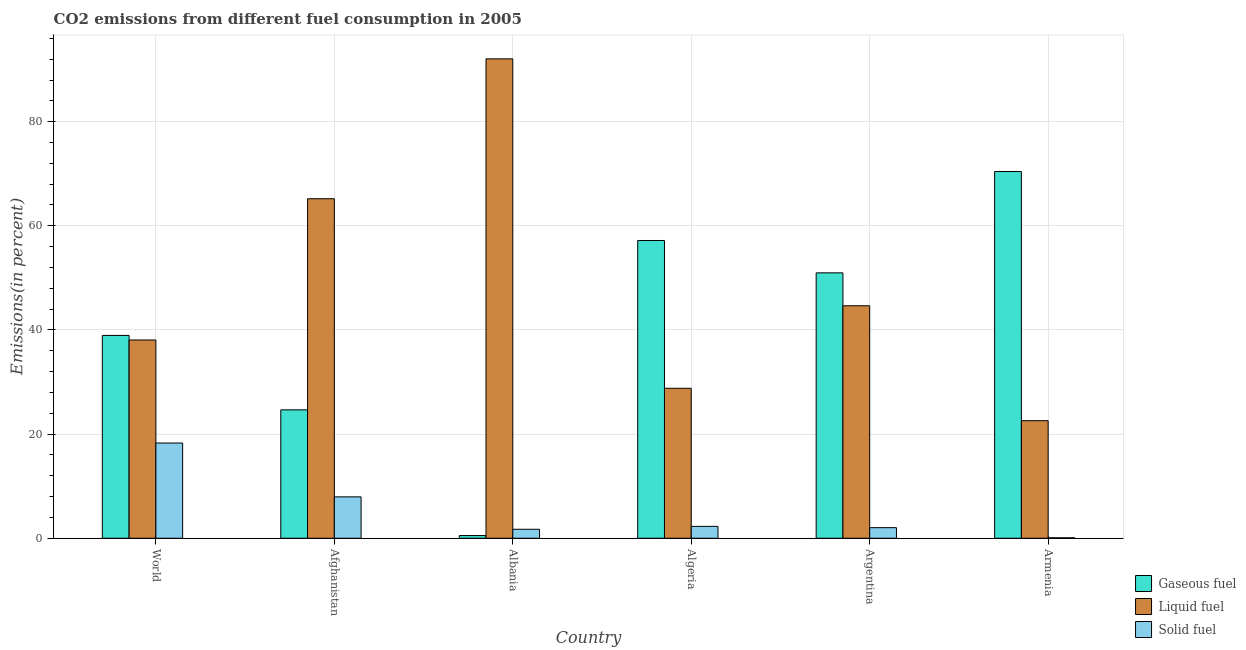How many groups of bars are there?
Offer a very short reply. 6. Are the number of bars per tick equal to the number of legend labels?
Offer a terse response. Yes. What is the label of the 3rd group of bars from the left?
Give a very brief answer. Albania. What is the percentage of liquid fuel emission in World?
Keep it short and to the point. 38.08. Across all countries, what is the maximum percentage of gaseous fuel emission?
Your response must be concise. 70.43. Across all countries, what is the minimum percentage of liquid fuel emission?
Your answer should be very brief. 22.58. In which country was the percentage of gaseous fuel emission maximum?
Provide a short and direct response. Armenia. In which country was the percentage of solid fuel emission minimum?
Your answer should be compact. Armenia. What is the total percentage of liquid fuel emission in the graph?
Your response must be concise. 291.37. What is the difference between the percentage of solid fuel emission in Algeria and that in Armenia?
Offer a very short reply. 2.2. What is the difference between the percentage of liquid fuel emission in Argentina and the percentage of gaseous fuel emission in World?
Your answer should be very brief. 5.69. What is the average percentage of liquid fuel emission per country?
Ensure brevity in your answer.  48.56. What is the difference between the percentage of liquid fuel emission and percentage of solid fuel emission in World?
Provide a short and direct response. 19.79. What is the ratio of the percentage of liquid fuel emission in Albania to that in Armenia?
Offer a very short reply. 4.08. What is the difference between the highest and the second highest percentage of liquid fuel emission?
Your response must be concise. 26.86. What is the difference between the highest and the lowest percentage of solid fuel emission?
Your answer should be compact. 18.2. What does the 1st bar from the left in Argentina represents?
Your answer should be very brief. Gaseous fuel. What does the 1st bar from the right in World represents?
Your answer should be very brief. Solid fuel. Is it the case that in every country, the sum of the percentage of gaseous fuel emission and percentage of liquid fuel emission is greater than the percentage of solid fuel emission?
Provide a short and direct response. Yes. Are the values on the major ticks of Y-axis written in scientific E-notation?
Offer a terse response. No. How many legend labels are there?
Offer a very short reply. 3. How are the legend labels stacked?
Your answer should be compact. Vertical. What is the title of the graph?
Make the answer very short. CO2 emissions from different fuel consumption in 2005. What is the label or title of the X-axis?
Provide a succinct answer. Country. What is the label or title of the Y-axis?
Provide a succinct answer. Emissions(in percent). What is the Emissions(in percent) of Gaseous fuel in World?
Make the answer very short. 38.95. What is the Emissions(in percent) of Liquid fuel in World?
Provide a succinct answer. 38.08. What is the Emissions(in percent) of Solid fuel in World?
Your answer should be compact. 18.29. What is the Emissions(in percent) in Gaseous fuel in Afghanistan?
Offer a very short reply. 24.66. What is the Emissions(in percent) in Liquid fuel in Afghanistan?
Provide a short and direct response. 65.21. What is the Emissions(in percent) in Solid fuel in Afghanistan?
Ensure brevity in your answer.  7.95. What is the Emissions(in percent) of Gaseous fuel in Albania?
Make the answer very short. 0.52. What is the Emissions(in percent) of Liquid fuel in Albania?
Your answer should be compact. 92.07. What is the Emissions(in percent) of Solid fuel in Albania?
Give a very brief answer. 1.72. What is the Emissions(in percent) of Gaseous fuel in Algeria?
Make the answer very short. 57.18. What is the Emissions(in percent) of Liquid fuel in Algeria?
Ensure brevity in your answer.  28.8. What is the Emissions(in percent) in Solid fuel in Algeria?
Your answer should be very brief. 2.28. What is the Emissions(in percent) in Gaseous fuel in Argentina?
Offer a very short reply. 50.97. What is the Emissions(in percent) of Liquid fuel in Argentina?
Provide a short and direct response. 44.65. What is the Emissions(in percent) in Solid fuel in Argentina?
Offer a very short reply. 2.03. What is the Emissions(in percent) of Gaseous fuel in Armenia?
Your response must be concise. 70.43. What is the Emissions(in percent) of Liquid fuel in Armenia?
Offer a terse response. 22.58. What is the Emissions(in percent) of Solid fuel in Armenia?
Keep it short and to the point. 0.08. Across all countries, what is the maximum Emissions(in percent) of Gaseous fuel?
Ensure brevity in your answer.  70.43. Across all countries, what is the maximum Emissions(in percent) of Liquid fuel?
Make the answer very short. 92.07. Across all countries, what is the maximum Emissions(in percent) of Solid fuel?
Make the answer very short. 18.29. Across all countries, what is the minimum Emissions(in percent) in Gaseous fuel?
Ensure brevity in your answer.  0.52. Across all countries, what is the minimum Emissions(in percent) of Liquid fuel?
Provide a succinct answer. 22.58. Across all countries, what is the minimum Emissions(in percent) in Solid fuel?
Make the answer very short. 0.08. What is the total Emissions(in percent) of Gaseous fuel in the graph?
Give a very brief answer. 242.71. What is the total Emissions(in percent) of Liquid fuel in the graph?
Provide a short and direct response. 291.37. What is the total Emissions(in percent) of Solid fuel in the graph?
Your response must be concise. 32.35. What is the difference between the Emissions(in percent) in Gaseous fuel in World and that in Afghanistan?
Your answer should be very brief. 14.3. What is the difference between the Emissions(in percent) of Liquid fuel in World and that in Afghanistan?
Make the answer very short. -27.13. What is the difference between the Emissions(in percent) in Solid fuel in World and that in Afghanistan?
Ensure brevity in your answer.  10.34. What is the difference between the Emissions(in percent) of Gaseous fuel in World and that in Albania?
Your answer should be very brief. 38.44. What is the difference between the Emissions(in percent) of Liquid fuel in World and that in Albania?
Keep it short and to the point. -53.99. What is the difference between the Emissions(in percent) of Solid fuel in World and that in Albania?
Make the answer very short. 16.56. What is the difference between the Emissions(in percent) in Gaseous fuel in World and that in Algeria?
Provide a short and direct response. -18.23. What is the difference between the Emissions(in percent) of Liquid fuel in World and that in Algeria?
Provide a succinct answer. 9.28. What is the difference between the Emissions(in percent) of Solid fuel in World and that in Algeria?
Give a very brief answer. 16.01. What is the difference between the Emissions(in percent) of Gaseous fuel in World and that in Argentina?
Your response must be concise. -12.01. What is the difference between the Emissions(in percent) in Liquid fuel in World and that in Argentina?
Make the answer very short. -6.57. What is the difference between the Emissions(in percent) of Solid fuel in World and that in Argentina?
Your response must be concise. 16.26. What is the difference between the Emissions(in percent) in Gaseous fuel in World and that in Armenia?
Your answer should be compact. -31.47. What is the difference between the Emissions(in percent) in Liquid fuel in World and that in Armenia?
Your answer should be compact. 15.5. What is the difference between the Emissions(in percent) in Solid fuel in World and that in Armenia?
Provide a succinct answer. 18.2. What is the difference between the Emissions(in percent) of Gaseous fuel in Afghanistan and that in Albania?
Ensure brevity in your answer.  24.14. What is the difference between the Emissions(in percent) in Liquid fuel in Afghanistan and that in Albania?
Your answer should be very brief. -26.86. What is the difference between the Emissions(in percent) in Solid fuel in Afghanistan and that in Albania?
Offer a terse response. 6.22. What is the difference between the Emissions(in percent) in Gaseous fuel in Afghanistan and that in Algeria?
Your answer should be compact. -32.53. What is the difference between the Emissions(in percent) of Liquid fuel in Afghanistan and that in Algeria?
Provide a succinct answer. 36.41. What is the difference between the Emissions(in percent) in Solid fuel in Afghanistan and that in Algeria?
Make the answer very short. 5.67. What is the difference between the Emissions(in percent) in Gaseous fuel in Afghanistan and that in Argentina?
Give a very brief answer. -26.31. What is the difference between the Emissions(in percent) of Liquid fuel in Afghanistan and that in Argentina?
Your answer should be very brief. 20.56. What is the difference between the Emissions(in percent) in Solid fuel in Afghanistan and that in Argentina?
Offer a terse response. 5.91. What is the difference between the Emissions(in percent) in Gaseous fuel in Afghanistan and that in Armenia?
Give a very brief answer. -45.77. What is the difference between the Emissions(in percent) in Liquid fuel in Afghanistan and that in Armenia?
Your response must be concise. 42.63. What is the difference between the Emissions(in percent) in Solid fuel in Afghanistan and that in Armenia?
Your response must be concise. 7.86. What is the difference between the Emissions(in percent) of Gaseous fuel in Albania and that in Algeria?
Provide a succinct answer. -56.67. What is the difference between the Emissions(in percent) in Liquid fuel in Albania and that in Algeria?
Your answer should be very brief. 63.27. What is the difference between the Emissions(in percent) in Solid fuel in Albania and that in Algeria?
Offer a very short reply. -0.56. What is the difference between the Emissions(in percent) of Gaseous fuel in Albania and that in Argentina?
Offer a very short reply. -50.45. What is the difference between the Emissions(in percent) in Liquid fuel in Albania and that in Argentina?
Offer a very short reply. 47.42. What is the difference between the Emissions(in percent) of Solid fuel in Albania and that in Argentina?
Make the answer very short. -0.31. What is the difference between the Emissions(in percent) of Gaseous fuel in Albania and that in Armenia?
Your answer should be compact. -69.91. What is the difference between the Emissions(in percent) of Liquid fuel in Albania and that in Armenia?
Offer a terse response. 69.49. What is the difference between the Emissions(in percent) in Solid fuel in Albania and that in Armenia?
Provide a short and direct response. 1.64. What is the difference between the Emissions(in percent) in Gaseous fuel in Algeria and that in Argentina?
Keep it short and to the point. 6.22. What is the difference between the Emissions(in percent) in Liquid fuel in Algeria and that in Argentina?
Keep it short and to the point. -15.85. What is the difference between the Emissions(in percent) in Solid fuel in Algeria and that in Argentina?
Provide a short and direct response. 0.25. What is the difference between the Emissions(in percent) in Gaseous fuel in Algeria and that in Armenia?
Provide a short and direct response. -13.24. What is the difference between the Emissions(in percent) of Liquid fuel in Algeria and that in Armenia?
Offer a terse response. 6.22. What is the difference between the Emissions(in percent) of Solid fuel in Algeria and that in Armenia?
Ensure brevity in your answer.  2.2. What is the difference between the Emissions(in percent) in Gaseous fuel in Argentina and that in Armenia?
Give a very brief answer. -19.46. What is the difference between the Emissions(in percent) of Liquid fuel in Argentina and that in Armenia?
Give a very brief answer. 22.07. What is the difference between the Emissions(in percent) of Solid fuel in Argentina and that in Armenia?
Ensure brevity in your answer.  1.95. What is the difference between the Emissions(in percent) in Gaseous fuel in World and the Emissions(in percent) in Liquid fuel in Afghanistan?
Give a very brief answer. -26.25. What is the difference between the Emissions(in percent) in Gaseous fuel in World and the Emissions(in percent) in Solid fuel in Afghanistan?
Provide a succinct answer. 31.01. What is the difference between the Emissions(in percent) in Liquid fuel in World and the Emissions(in percent) in Solid fuel in Afghanistan?
Offer a very short reply. 30.13. What is the difference between the Emissions(in percent) in Gaseous fuel in World and the Emissions(in percent) in Liquid fuel in Albania?
Offer a very short reply. -53.11. What is the difference between the Emissions(in percent) in Gaseous fuel in World and the Emissions(in percent) in Solid fuel in Albania?
Make the answer very short. 37.23. What is the difference between the Emissions(in percent) in Liquid fuel in World and the Emissions(in percent) in Solid fuel in Albania?
Your response must be concise. 36.35. What is the difference between the Emissions(in percent) in Gaseous fuel in World and the Emissions(in percent) in Liquid fuel in Algeria?
Make the answer very short. 10.16. What is the difference between the Emissions(in percent) in Gaseous fuel in World and the Emissions(in percent) in Solid fuel in Algeria?
Make the answer very short. 36.68. What is the difference between the Emissions(in percent) in Liquid fuel in World and the Emissions(in percent) in Solid fuel in Algeria?
Make the answer very short. 35.8. What is the difference between the Emissions(in percent) in Gaseous fuel in World and the Emissions(in percent) in Liquid fuel in Argentina?
Provide a succinct answer. -5.69. What is the difference between the Emissions(in percent) in Gaseous fuel in World and the Emissions(in percent) in Solid fuel in Argentina?
Your answer should be compact. 36.92. What is the difference between the Emissions(in percent) in Liquid fuel in World and the Emissions(in percent) in Solid fuel in Argentina?
Keep it short and to the point. 36.04. What is the difference between the Emissions(in percent) in Gaseous fuel in World and the Emissions(in percent) in Liquid fuel in Armenia?
Provide a succinct answer. 16.38. What is the difference between the Emissions(in percent) of Gaseous fuel in World and the Emissions(in percent) of Solid fuel in Armenia?
Make the answer very short. 38.87. What is the difference between the Emissions(in percent) in Liquid fuel in World and the Emissions(in percent) in Solid fuel in Armenia?
Your answer should be very brief. 37.99. What is the difference between the Emissions(in percent) of Gaseous fuel in Afghanistan and the Emissions(in percent) of Liquid fuel in Albania?
Your answer should be very brief. -67.41. What is the difference between the Emissions(in percent) of Gaseous fuel in Afghanistan and the Emissions(in percent) of Solid fuel in Albania?
Your answer should be very brief. 22.93. What is the difference between the Emissions(in percent) of Liquid fuel in Afghanistan and the Emissions(in percent) of Solid fuel in Albania?
Keep it short and to the point. 63.48. What is the difference between the Emissions(in percent) in Gaseous fuel in Afghanistan and the Emissions(in percent) in Liquid fuel in Algeria?
Provide a succinct answer. -4.14. What is the difference between the Emissions(in percent) of Gaseous fuel in Afghanistan and the Emissions(in percent) of Solid fuel in Algeria?
Offer a very short reply. 22.38. What is the difference between the Emissions(in percent) in Liquid fuel in Afghanistan and the Emissions(in percent) in Solid fuel in Algeria?
Your answer should be very brief. 62.93. What is the difference between the Emissions(in percent) of Gaseous fuel in Afghanistan and the Emissions(in percent) of Liquid fuel in Argentina?
Ensure brevity in your answer.  -19.99. What is the difference between the Emissions(in percent) in Gaseous fuel in Afghanistan and the Emissions(in percent) in Solid fuel in Argentina?
Provide a succinct answer. 22.63. What is the difference between the Emissions(in percent) of Liquid fuel in Afghanistan and the Emissions(in percent) of Solid fuel in Argentina?
Provide a succinct answer. 63.17. What is the difference between the Emissions(in percent) of Gaseous fuel in Afghanistan and the Emissions(in percent) of Liquid fuel in Armenia?
Give a very brief answer. 2.08. What is the difference between the Emissions(in percent) of Gaseous fuel in Afghanistan and the Emissions(in percent) of Solid fuel in Armenia?
Offer a very short reply. 24.57. What is the difference between the Emissions(in percent) of Liquid fuel in Afghanistan and the Emissions(in percent) of Solid fuel in Armenia?
Your answer should be very brief. 65.12. What is the difference between the Emissions(in percent) of Gaseous fuel in Albania and the Emissions(in percent) of Liquid fuel in Algeria?
Give a very brief answer. -28.28. What is the difference between the Emissions(in percent) of Gaseous fuel in Albania and the Emissions(in percent) of Solid fuel in Algeria?
Your answer should be compact. -1.76. What is the difference between the Emissions(in percent) in Liquid fuel in Albania and the Emissions(in percent) in Solid fuel in Algeria?
Your response must be concise. 89.79. What is the difference between the Emissions(in percent) in Gaseous fuel in Albania and the Emissions(in percent) in Liquid fuel in Argentina?
Your response must be concise. -44.13. What is the difference between the Emissions(in percent) in Gaseous fuel in Albania and the Emissions(in percent) in Solid fuel in Argentina?
Keep it short and to the point. -1.51. What is the difference between the Emissions(in percent) of Liquid fuel in Albania and the Emissions(in percent) of Solid fuel in Argentina?
Your answer should be very brief. 90.04. What is the difference between the Emissions(in percent) in Gaseous fuel in Albania and the Emissions(in percent) in Liquid fuel in Armenia?
Your response must be concise. -22.06. What is the difference between the Emissions(in percent) in Gaseous fuel in Albania and the Emissions(in percent) in Solid fuel in Armenia?
Provide a short and direct response. 0.43. What is the difference between the Emissions(in percent) in Liquid fuel in Albania and the Emissions(in percent) in Solid fuel in Armenia?
Your answer should be compact. 91.98. What is the difference between the Emissions(in percent) in Gaseous fuel in Algeria and the Emissions(in percent) in Liquid fuel in Argentina?
Ensure brevity in your answer.  12.54. What is the difference between the Emissions(in percent) in Gaseous fuel in Algeria and the Emissions(in percent) in Solid fuel in Argentina?
Your answer should be very brief. 55.15. What is the difference between the Emissions(in percent) in Liquid fuel in Algeria and the Emissions(in percent) in Solid fuel in Argentina?
Ensure brevity in your answer.  26.77. What is the difference between the Emissions(in percent) in Gaseous fuel in Algeria and the Emissions(in percent) in Liquid fuel in Armenia?
Your response must be concise. 34.61. What is the difference between the Emissions(in percent) in Gaseous fuel in Algeria and the Emissions(in percent) in Solid fuel in Armenia?
Your response must be concise. 57.1. What is the difference between the Emissions(in percent) in Liquid fuel in Algeria and the Emissions(in percent) in Solid fuel in Armenia?
Your answer should be compact. 28.71. What is the difference between the Emissions(in percent) of Gaseous fuel in Argentina and the Emissions(in percent) of Liquid fuel in Armenia?
Your response must be concise. 28.39. What is the difference between the Emissions(in percent) of Gaseous fuel in Argentina and the Emissions(in percent) of Solid fuel in Armenia?
Provide a short and direct response. 50.88. What is the difference between the Emissions(in percent) of Liquid fuel in Argentina and the Emissions(in percent) of Solid fuel in Armenia?
Offer a terse response. 44.56. What is the average Emissions(in percent) in Gaseous fuel per country?
Provide a short and direct response. 40.45. What is the average Emissions(in percent) in Liquid fuel per country?
Provide a succinct answer. 48.56. What is the average Emissions(in percent) in Solid fuel per country?
Your answer should be very brief. 5.39. What is the difference between the Emissions(in percent) of Gaseous fuel and Emissions(in percent) of Liquid fuel in World?
Offer a very short reply. 0.88. What is the difference between the Emissions(in percent) in Gaseous fuel and Emissions(in percent) in Solid fuel in World?
Your response must be concise. 20.67. What is the difference between the Emissions(in percent) in Liquid fuel and Emissions(in percent) in Solid fuel in World?
Offer a very short reply. 19.79. What is the difference between the Emissions(in percent) of Gaseous fuel and Emissions(in percent) of Liquid fuel in Afghanistan?
Offer a terse response. -40.55. What is the difference between the Emissions(in percent) in Gaseous fuel and Emissions(in percent) in Solid fuel in Afghanistan?
Offer a very short reply. 16.71. What is the difference between the Emissions(in percent) of Liquid fuel and Emissions(in percent) of Solid fuel in Afghanistan?
Your answer should be very brief. 57.26. What is the difference between the Emissions(in percent) of Gaseous fuel and Emissions(in percent) of Liquid fuel in Albania?
Provide a succinct answer. -91.55. What is the difference between the Emissions(in percent) of Gaseous fuel and Emissions(in percent) of Solid fuel in Albania?
Provide a succinct answer. -1.21. What is the difference between the Emissions(in percent) in Liquid fuel and Emissions(in percent) in Solid fuel in Albania?
Your response must be concise. 90.34. What is the difference between the Emissions(in percent) in Gaseous fuel and Emissions(in percent) in Liquid fuel in Algeria?
Offer a terse response. 28.39. What is the difference between the Emissions(in percent) in Gaseous fuel and Emissions(in percent) in Solid fuel in Algeria?
Ensure brevity in your answer.  54.91. What is the difference between the Emissions(in percent) of Liquid fuel and Emissions(in percent) of Solid fuel in Algeria?
Provide a short and direct response. 26.52. What is the difference between the Emissions(in percent) of Gaseous fuel and Emissions(in percent) of Liquid fuel in Argentina?
Offer a terse response. 6.32. What is the difference between the Emissions(in percent) of Gaseous fuel and Emissions(in percent) of Solid fuel in Argentina?
Make the answer very short. 48.94. What is the difference between the Emissions(in percent) in Liquid fuel and Emissions(in percent) in Solid fuel in Argentina?
Provide a short and direct response. 42.61. What is the difference between the Emissions(in percent) of Gaseous fuel and Emissions(in percent) of Liquid fuel in Armenia?
Make the answer very short. 47.85. What is the difference between the Emissions(in percent) of Gaseous fuel and Emissions(in percent) of Solid fuel in Armenia?
Keep it short and to the point. 70.35. What is the difference between the Emissions(in percent) in Liquid fuel and Emissions(in percent) in Solid fuel in Armenia?
Your answer should be compact. 22.49. What is the ratio of the Emissions(in percent) of Gaseous fuel in World to that in Afghanistan?
Your answer should be compact. 1.58. What is the ratio of the Emissions(in percent) of Liquid fuel in World to that in Afghanistan?
Make the answer very short. 0.58. What is the ratio of the Emissions(in percent) of Solid fuel in World to that in Afghanistan?
Your answer should be very brief. 2.3. What is the ratio of the Emissions(in percent) of Gaseous fuel in World to that in Albania?
Ensure brevity in your answer.  75.31. What is the ratio of the Emissions(in percent) in Liquid fuel in World to that in Albania?
Keep it short and to the point. 0.41. What is the ratio of the Emissions(in percent) of Solid fuel in World to that in Albania?
Give a very brief answer. 10.61. What is the ratio of the Emissions(in percent) in Gaseous fuel in World to that in Algeria?
Your answer should be very brief. 0.68. What is the ratio of the Emissions(in percent) of Liquid fuel in World to that in Algeria?
Give a very brief answer. 1.32. What is the ratio of the Emissions(in percent) in Solid fuel in World to that in Algeria?
Your answer should be compact. 8.02. What is the ratio of the Emissions(in percent) in Gaseous fuel in World to that in Argentina?
Give a very brief answer. 0.76. What is the ratio of the Emissions(in percent) in Liquid fuel in World to that in Argentina?
Your response must be concise. 0.85. What is the ratio of the Emissions(in percent) of Solid fuel in World to that in Argentina?
Keep it short and to the point. 9. What is the ratio of the Emissions(in percent) of Gaseous fuel in World to that in Armenia?
Give a very brief answer. 0.55. What is the ratio of the Emissions(in percent) of Liquid fuel in World to that in Armenia?
Your answer should be very brief. 1.69. What is the ratio of the Emissions(in percent) in Solid fuel in World to that in Armenia?
Your answer should be compact. 217.09. What is the ratio of the Emissions(in percent) of Gaseous fuel in Afghanistan to that in Albania?
Provide a succinct answer. 47.67. What is the ratio of the Emissions(in percent) in Liquid fuel in Afghanistan to that in Albania?
Keep it short and to the point. 0.71. What is the ratio of the Emissions(in percent) of Solid fuel in Afghanistan to that in Albania?
Provide a short and direct response. 4.61. What is the ratio of the Emissions(in percent) of Gaseous fuel in Afghanistan to that in Algeria?
Provide a succinct answer. 0.43. What is the ratio of the Emissions(in percent) of Liquid fuel in Afghanistan to that in Algeria?
Ensure brevity in your answer.  2.26. What is the ratio of the Emissions(in percent) of Solid fuel in Afghanistan to that in Algeria?
Offer a terse response. 3.49. What is the ratio of the Emissions(in percent) of Gaseous fuel in Afghanistan to that in Argentina?
Offer a very short reply. 0.48. What is the ratio of the Emissions(in percent) of Liquid fuel in Afghanistan to that in Argentina?
Keep it short and to the point. 1.46. What is the ratio of the Emissions(in percent) of Solid fuel in Afghanistan to that in Argentina?
Give a very brief answer. 3.91. What is the ratio of the Emissions(in percent) of Gaseous fuel in Afghanistan to that in Armenia?
Provide a succinct answer. 0.35. What is the ratio of the Emissions(in percent) of Liquid fuel in Afghanistan to that in Armenia?
Offer a very short reply. 2.89. What is the ratio of the Emissions(in percent) of Solid fuel in Afghanistan to that in Armenia?
Your answer should be very brief. 94.31. What is the ratio of the Emissions(in percent) in Gaseous fuel in Albania to that in Algeria?
Ensure brevity in your answer.  0.01. What is the ratio of the Emissions(in percent) in Liquid fuel in Albania to that in Algeria?
Your answer should be compact. 3.2. What is the ratio of the Emissions(in percent) in Solid fuel in Albania to that in Algeria?
Ensure brevity in your answer.  0.76. What is the ratio of the Emissions(in percent) of Gaseous fuel in Albania to that in Argentina?
Provide a short and direct response. 0.01. What is the ratio of the Emissions(in percent) of Liquid fuel in Albania to that in Argentina?
Provide a short and direct response. 2.06. What is the ratio of the Emissions(in percent) in Solid fuel in Albania to that in Argentina?
Offer a very short reply. 0.85. What is the ratio of the Emissions(in percent) of Gaseous fuel in Albania to that in Armenia?
Provide a succinct answer. 0.01. What is the ratio of the Emissions(in percent) in Liquid fuel in Albania to that in Armenia?
Offer a terse response. 4.08. What is the ratio of the Emissions(in percent) in Solid fuel in Albania to that in Armenia?
Your response must be concise. 20.47. What is the ratio of the Emissions(in percent) in Gaseous fuel in Algeria to that in Argentina?
Provide a succinct answer. 1.12. What is the ratio of the Emissions(in percent) of Liquid fuel in Algeria to that in Argentina?
Keep it short and to the point. 0.65. What is the ratio of the Emissions(in percent) of Solid fuel in Algeria to that in Argentina?
Provide a succinct answer. 1.12. What is the ratio of the Emissions(in percent) in Gaseous fuel in Algeria to that in Armenia?
Your answer should be compact. 0.81. What is the ratio of the Emissions(in percent) in Liquid fuel in Algeria to that in Armenia?
Offer a very short reply. 1.28. What is the ratio of the Emissions(in percent) in Solid fuel in Algeria to that in Armenia?
Keep it short and to the point. 27.06. What is the ratio of the Emissions(in percent) in Gaseous fuel in Argentina to that in Armenia?
Your answer should be compact. 0.72. What is the ratio of the Emissions(in percent) in Liquid fuel in Argentina to that in Armenia?
Offer a terse response. 1.98. What is the ratio of the Emissions(in percent) of Solid fuel in Argentina to that in Armenia?
Offer a very short reply. 24.12. What is the difference between the highest and the second highest Emissions(in percent) of Gaseous fuel?
Ensure brevity in your answer.  13.24. What is the difference between the highest and the second highest Emissions(in percent) of Liquid fuel?
Your response must be concise. 26.86. What is the difference between the highest and the second highest Emissions(in percent) of Solid fuel?
Your answer should be very brief. 10.34. What is the difference between the highest and the lowest Emissions(in percent) in Gaseous fuel?
Keep it short and to the point. 69.91. What is the difference between the highest and the lowest Emissions(in percent) in Liquid fuel?
Make the answer very short. 69.49. What is the difference between the highest and the lowest Emissions(in percent) of Solid fuel?
Offer a very short reply. 18.2. 